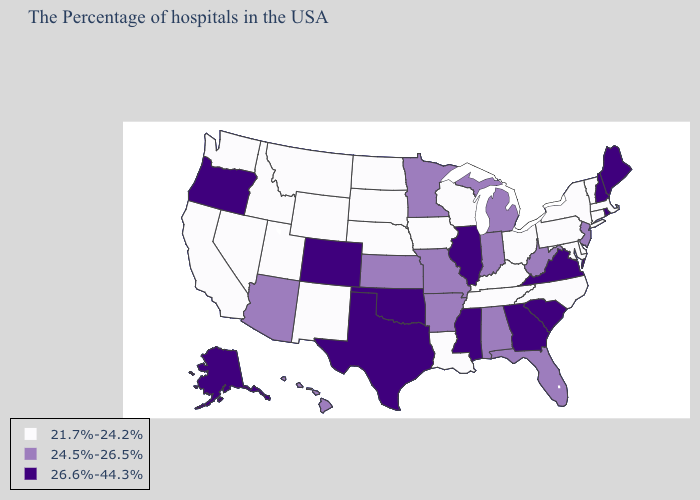Name the states that have a value in the range 24.5%-26.5%?
Write a very short answer. New Jersey, West Virginia, Florida, Michigan, Indiana, Alabama, Missouri, Arkansas, Minnesota, Kansas, Arizona, Hawaii. Name the states that have a value in the range 21.7%-24.2%?
Keep it brief. Massachusetts, Vermont, Connecticut, New York, Delaware, Maryland, Pennsylvania, North Carolina, Ohio, Kentucky, Tennessee, Wisconsin, Louisiana, Iowa, Nebraska, South Dakota, North Dakota, Wyoming, New Mexico, Utah, Montana, Idaho, Nevada, California, Washington. Name the states that have a value in the range 26.6%-44.3%?
Concise answer only. Maine, Rhode Island, New Hampshire, Virginia, South Carolina, Georgia, Illinois, Mississippi, Oklahoma, Texas, Colorado, Oregon, Alaska. Name the states that have a value in the range 24.5%-26.5%?
Give a very brief answer. New Jersey, West Virginia, Florida, Michigan, Indiana, Alabama, Missouri, Arkansas, Minnesota, Kansas, Arizona, Hawaii. Does Nevada have the lowest value in the USA?
Answer briefly. Yes. Name the states that have a value in the range 24.5%-26.5%?
Answer briefly. New Jersey, West Virginia, Florida, Michigan, Indiana, Alabama, Missouri, Arkansas, Minnesota, Kansas, Arizona, Hawaii. What is the value of Delaware?
Short answer required. 21.7%-24.2%. Which states hav the highest value in the South?
Quick response, please. Virginia, South Carolina, Georgia, Mississippi, Oklahoma, Texas. Name the states that have a value in the range 24.5%-26.5%?
Concise answer only. New Jersey, West Virginia, Florida, Michigan, Indiana, Alabama, Missouri, Arkansas, Minnesota, Kansas, Arizona, Hawaii. Name the states that have a value in the range 21.7%-24.2%?
Quick response, please. Massachusetts, Vermont, Connecticut, New York, Delaware, Maryland, Pennsylvania, North Carolina, Ohio, Kentucky, Tennessee, Wisconsin, Louisiana, Iowa, Nebraska, South Dakota, North Dakota, Wyoming, New Mexico, Utah, Montana, Idaho, Nevada, California, Washington. Does Minnesota have the lowest value in the USA?
Short answer required. No. Does Mississippi have the highest value in the USA?
Give a very brief answer. Yes. What is the value of Pennsylvania?
Keep it brief. 21.7%-24.2%. Among the states that border Tennessee , which have the highest value?
Answer briefly. Virginia, Georgia, Mississippi. Does the first symbol in the legend represent the smallest category?
Quick response, please. Yes. 